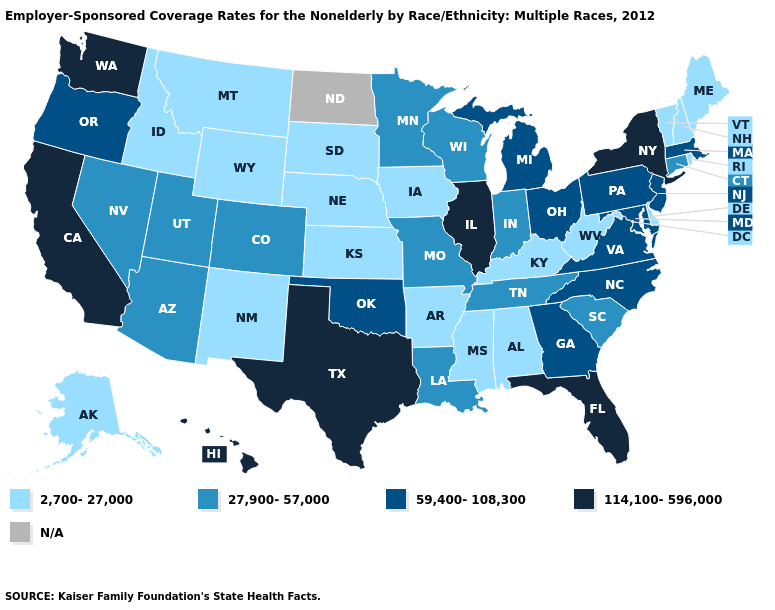What is the value of Wisconsin?
Give a very brief answer. 27,900-57,000. What is the lowest value in states that border Texas?
Give a very brief answer. 2,700-27,000. What is the value of Rhode Island?
Quick response, please. 2,700-27,000. Does Delaware have the lowest value in the South?
Short answer required. Yes. What is the value of Pennsylvania?
Give a very brief answer. 59,400-108,300. Which states have the lowest value in the Northeast?
Give a very brief answer. Maine, New Hampshire, Rhode Island, Vermont. How many symbols are there in the legend?
Concise answer only. 5. What is the value of Rhode Island?
Answer briefly. 2,700-27,000. Among the states that border Kentucky , which have the highest value?
Write a very short answer. Illinois. What is the highest value in states that border New York?
Give a very brief answer. 59,400-108,300. Name the states that have a value in the range 2,700-27,000?
Short answer required. Alabama, Alaska, Arkansas, Delaware, Idaho, Iowa, Kansas, Kentucky, Maine, Mississippi, Montana, Nebraska, New Hampshire, New Mexico, Rhode Island, South Dakota, Vermont, West Virginia, Wyoming. What is the highest value in the South ?
Short answer required. 114,100-596,000. Name the states that have a value in the range 59,400-108,300?
Concise answer only. Georgia, Maryland, Massachusetts, Michigan, New Jersey, North Carolina, Ohio, Oklahoma, Oregon, Pennsylvania, Virginia. Name the states that have a value in the range 2,700-27,000?
Answer briefly. Alabama, Alaska, Arkansas, Delaware, Idaho, Iowa, Kansas, Kentucky, Maine, Mississippi, Montana, Nebraska, New Hampshire, New Mexico, Rhode Island, South Dakota, Vermont, West Virginia, Wyoming. Which states have the highest value in the USA?
Write a very short answer. California, Florida, Hawaii, Illinois, New York, Texas, Washington. 